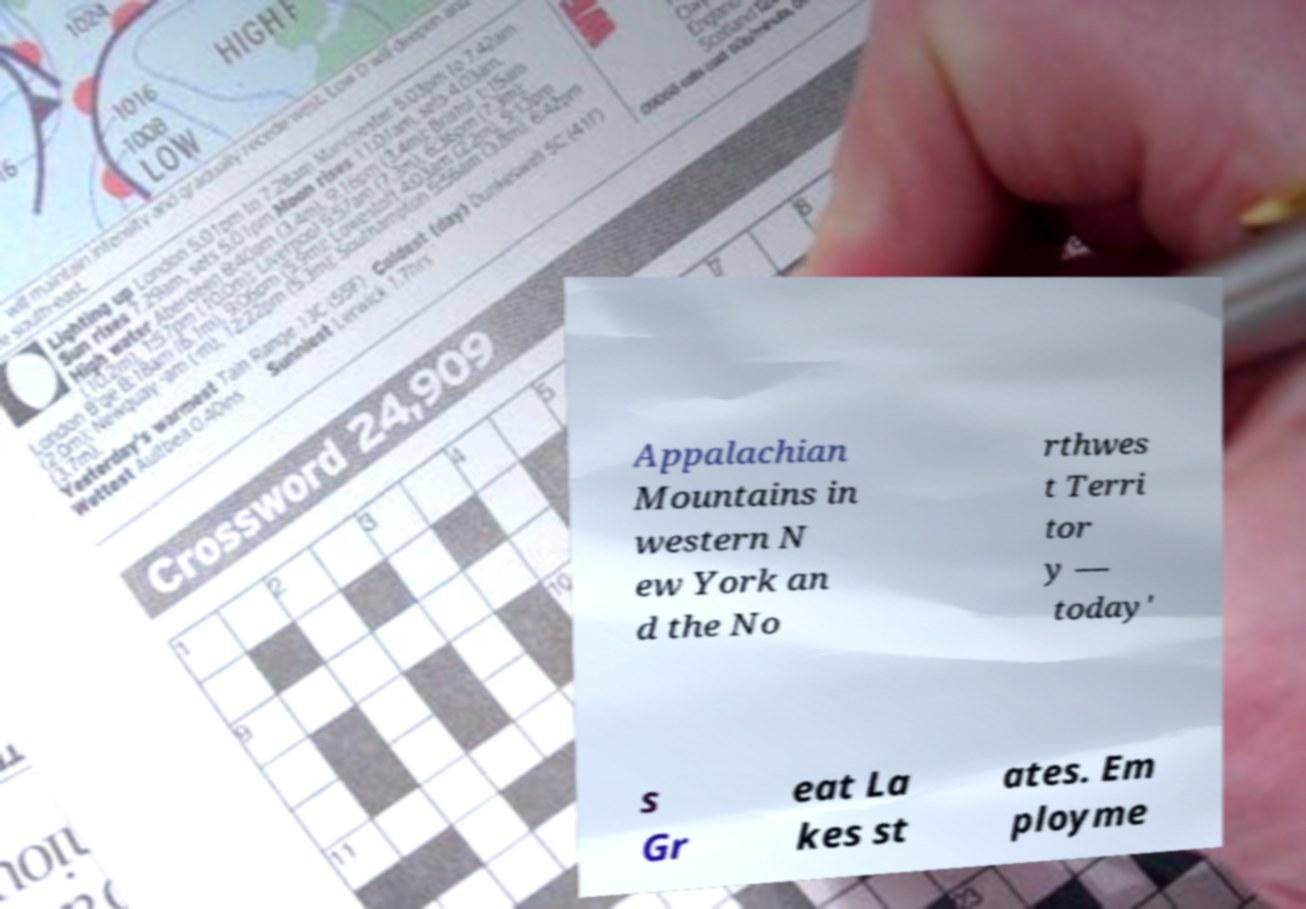For documentation purposes, I need the text within this image transcribed. Could you provide that? Appalachian Mountains in western N ew York an d the No rthwes t Terri tor y — today' s Gr eat La kes st ates. Em ployme 